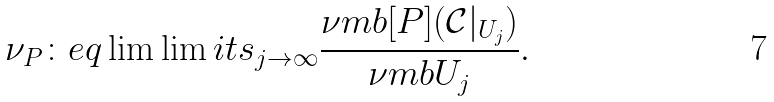<formula> <loc_0><loc_0><loc_500><loc_500>\nu _ { P } \colon e q \lim \lim i t s _ { j \rightarrow \infty } \frac { \nu m b [ P ] { ( { \mathcal { C } } | _ { U _ { j } } ) } } { \nu m b { U _ { j } } } .</formula> 